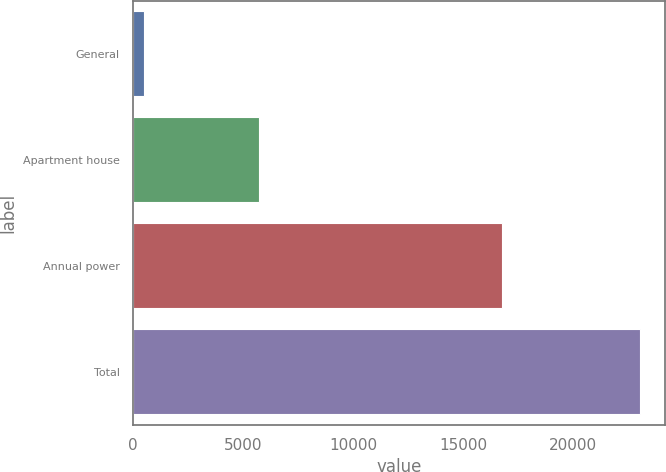<chart> <loc_0><loc_0><loc_500><loc_500><bar_chart><fcel>General<fcel>Apartment house<fcel>Annual power<fcel>Total<nl><fcel>515<fcel>5748<fcel>16767<fcel>23030<nl></chart> 